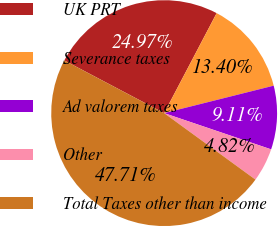Convert chart to OTSL. <chart><loc_0><loc_0><loc_500><loc_500><pie_chart><fcel>UK PRT<fcel>Severance taxes<fcel>Ad valorem taxes<fcel>Other<fcel>Total Taxes other than income<nl><fcel>24.97%<fcel>13.4%<fcel>9.11%<fcel>4.82%<fcel>47.72%<nl></chart> 